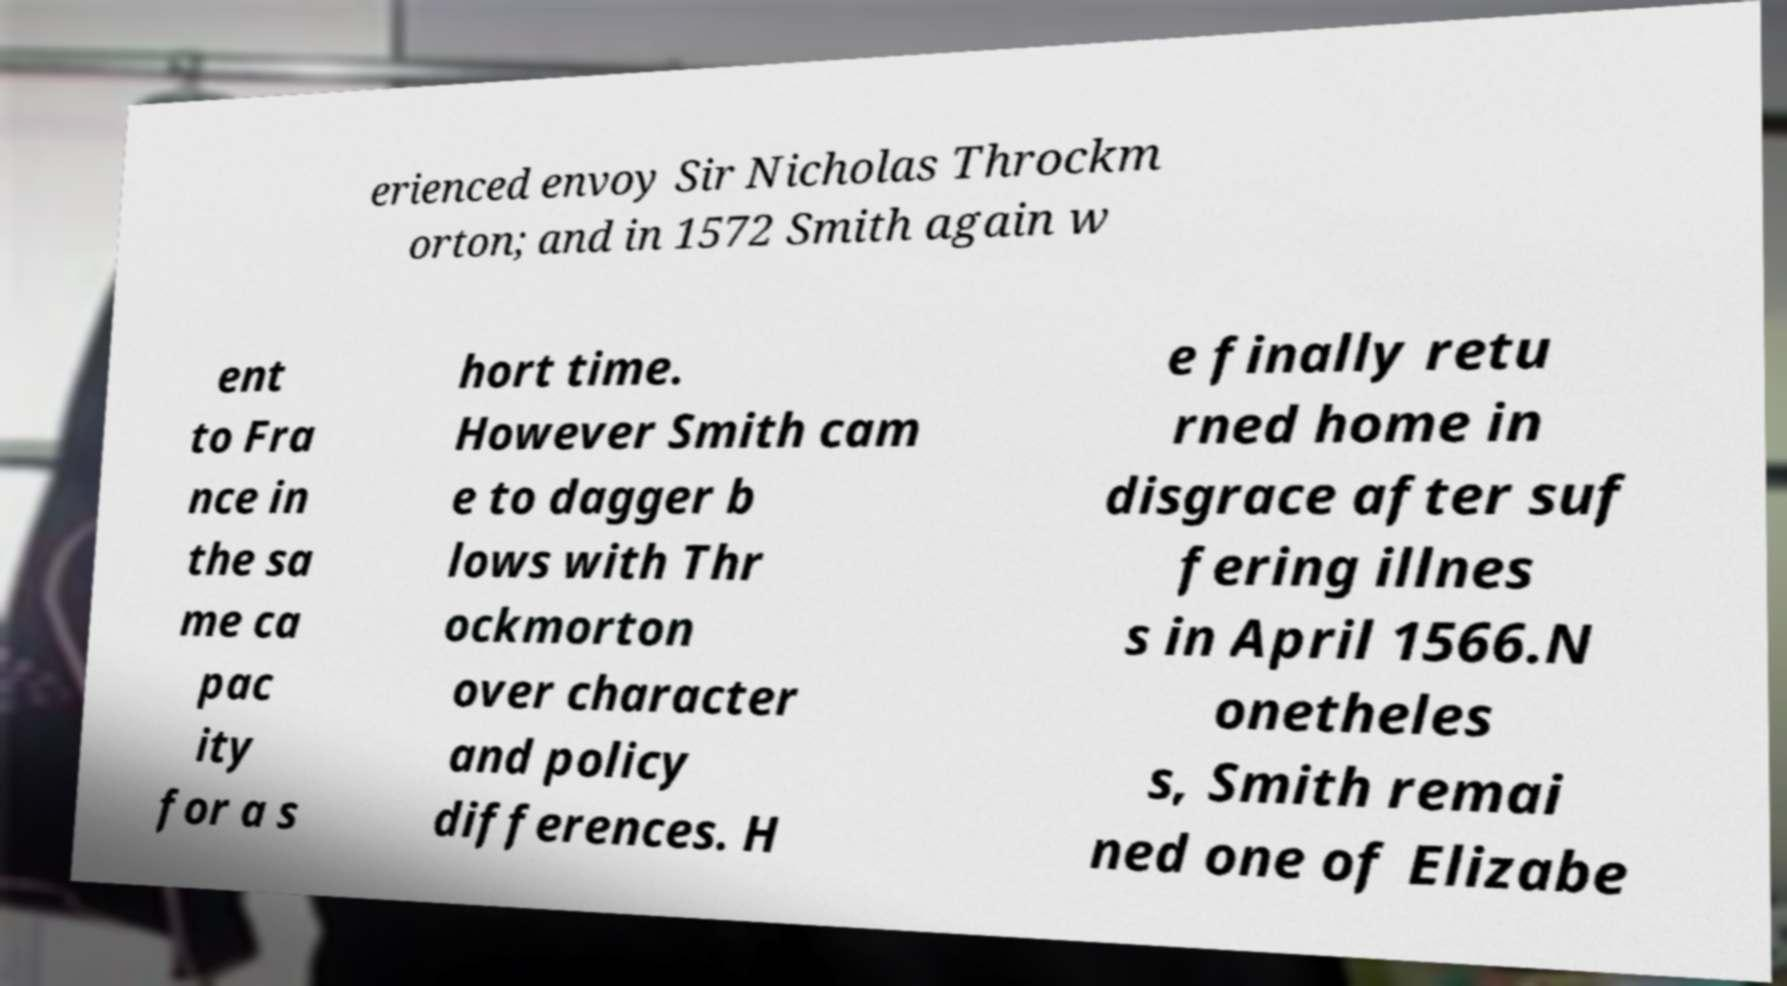For documentation purposes, I need the text within this image transcribed. Could you provide that? erienced envoy Sir Nicholas Throckm orton; and in 1572 Smith again w ent to Fra nce in the sa me ca pac ity for a s hort time. However Smith cam e to dagger b lows with Thr ockmorton over character and policy differences. H e finally retu rned home in disgrace after suf fering illnes s in April 1566.N onetheles s, Smith remai ned one of Elizabe 